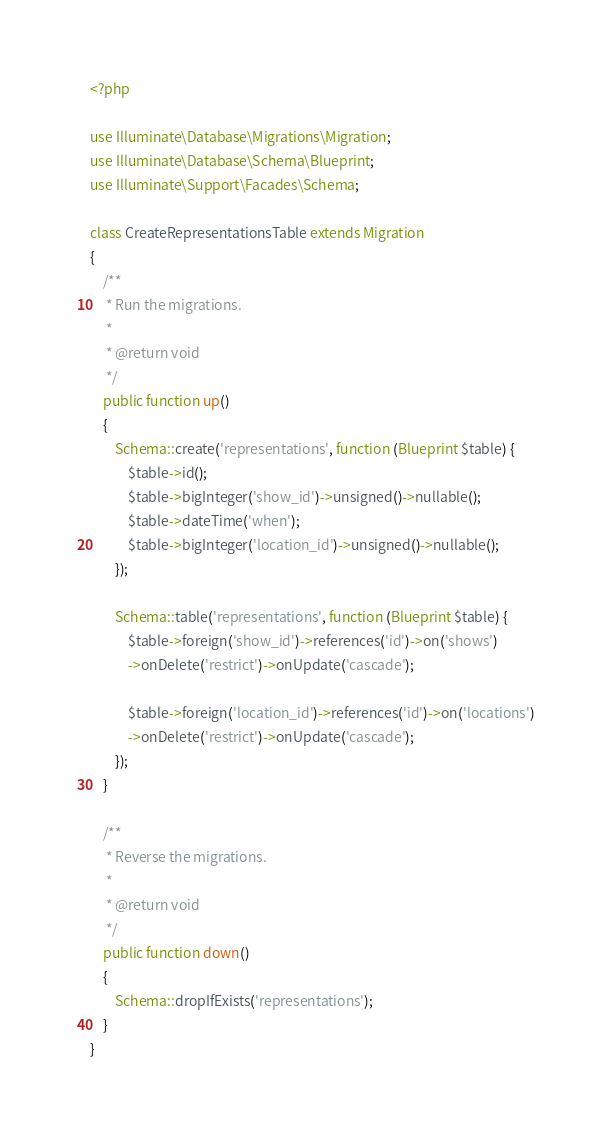<code> <loc_0><loc_0><loc_500><loc_500><_PHP_><?php

use Illuminate\Database\Migrations\Migration;
use Illuminate\Database\Schema\Blueprint;
use Illuminate\Support\Facades\Schema;

class CreateRepresentationsTable extends Migration
{
    /**
     * Run the migrations.
     *
     * @return void
     */
    public function up()
    {
        Schema::create('representations', function (Blueprint $table) {
            $table->id();
            $table->bigInteger('show_id')->unsigned()->nullable();
            $table->dateTime('when');
            $table->bigInteger('location_id')->unsigned()->nullable();
        });

        Schema::table('representations', function (Blueprint $table) {
            $table->foreign('show_id')->references('id')->on('shows')
            ->onDelete('restrict')->onUpdate('cascade');

            $table->foreign('location_id')->references('id')->on('locations')
            ->onDelete('restrict')->onUpdate('cascade');
        });
    }

    /**
     * Reverse the migrations.
     *
     * @return void
     */
    public function down()
    {
        Schema::dropIfExists('representations');
    }
}
</code> 